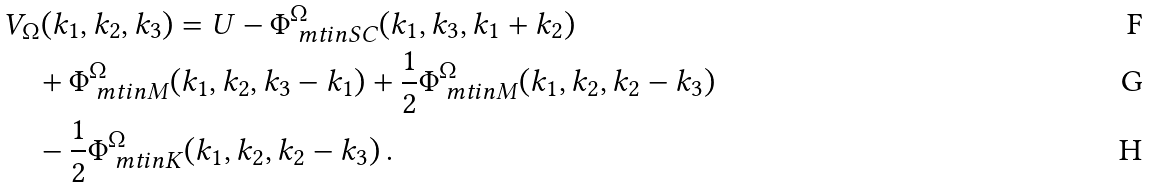Convert formula to latex. <formula><loc_0><loc_0><loc_500><loc_500>& V _ { \Omega } ( k _ { 1 } , k _ { 2 } , k _ { 3 } ) = U - \Phi _ { \ m t i n { S C } } ^ { \Omega } ( k _ { 1 } , k _ { 3 } , k _ { 1 } + k _ { 2 } ) \\ & \quad + \Phi _ { \ m t i n { M } } ^ { \Omega } ( k _ { 1 } , k _ { 2 } , k _ { 3 } - k _ { 1 } ) + \frac { 1 } { 2 } \Phi _ { \ m t i n { M } } ^ { \Omega } ( k _ { 1 } , k _ { 2 } , k _ { 2 } - k _ { 3 } ) \\ & \quad - \frac { 1 } { 2 } \Phi _ { \ m t i n { K } } ^ { \Omega } ( k _ { 1 } , k _ { 2 } , k _ { 2 } - k _ { 3 } ) \, .</formula> 